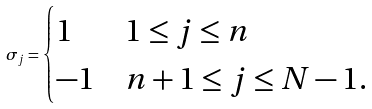<formula> <loc_0><loc_0><loc_500><loc_500>\sigma _ { j } = \begin{cases} 1 & 1 \leq j \leq n \\ - 1 & n + 1 \leq j \leq N - 1 . \end{cases}</formula> 